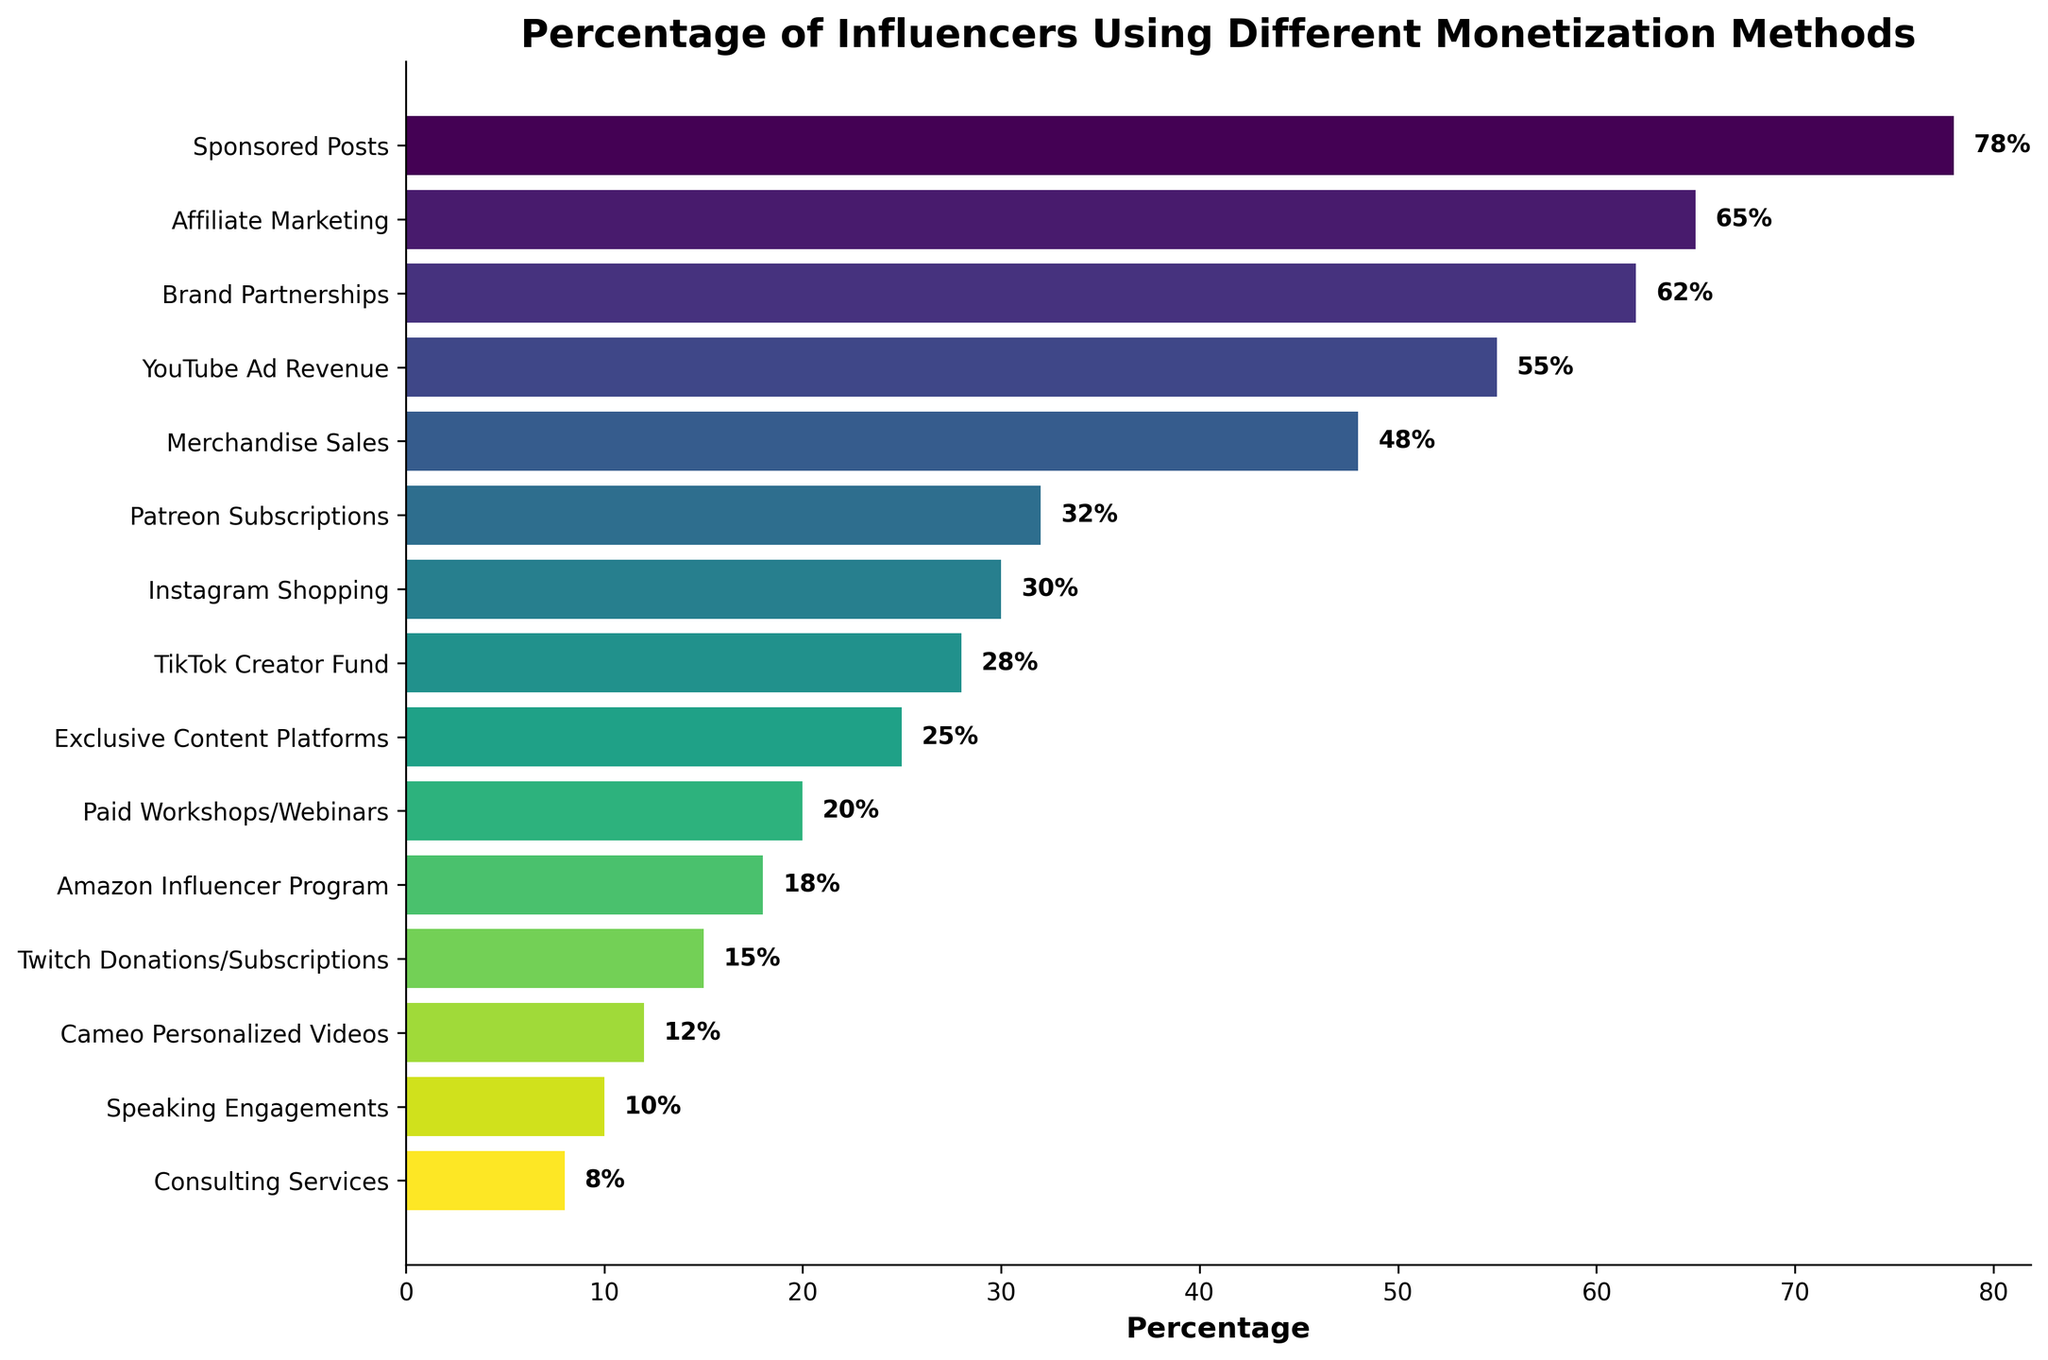Which monetization method is used by the highest percentage of influencers? The longest bar in the chart represents the method used by the highest percentage of influencers. This is indicated by the “Sponsored Posts” bar, which shows a percentage of 78%.
Answer: Sponsored Posts Which monetization method is used by the lowest percentage of influencers? The shortest bar in the chart represents the method used by the lowest percentage of influencers. This is indicated by the “Consulting Services” bar, which shows a percentage of 8%.
Answer: Consulting Services What is the percentage difference between influencers using Sponsored Posts and those using TikTok Creator Fund? The percentage for Sponsored Posts is 78% and for TikTok Creator Fund is 28%. The difference can be calculated by subtracting 28 from 78.
Answer: 50% Which monetization methods have a higher percentage of use than YouTube Ad Revenue? To determine this, identify the methods with bars longer than the YouTube Ad Revenue bar (55%). The methods are Sponsored Posts (78%), Affiliate Marketing (65%), and Brand Partnerships (62%).
Answer: Sponsored Posts, Affiliate Marketing, Brand Partnerships What is the average percentage of influencers using Affiliate Marketing, Brand Partnerships, and Merchandise Sales? The percentages are 65%, 62%, and 48%, respectively. Add these percentages and divide by 3 to find the average: (65 + 62 + 48) / 3 = 175 / 3.
Answer: 58.33% Do more influencers use Patreon Subscriptions or Instagram Shopping? Compare the lengths of the bars for Patreon Subscriptions (32%) and Instagram Shopping (30%). The bar for Patreon Subscriptions is slightly longer.
Answer: Patreon Subscriptions Which monetization method has a percentage closest to 25%? Look for the bar that is closest to 25%. The "Exclusive Content Platforms" method has a percentage of 25%.
Answer: Exclusive Content Platforms How many monetization methods are used by more than 50% of influencers? Count the number of bars with percentages greater than 50%. The methods are Sponsored Posts (78%), Affiliate Marketing (65%), Brand Partnerships (62%), and YouTube Ad Revenue (55%), totaling 4.
Answer: 4 By what percentage do more influencers use Sponsored Posts compared to Merchandise Sales? The percentage for Sponsored Posts is 78% and for Merchandise Sales is 48%. Subtract 48 from 78 to find the difference.
Answer: 30% What is the combined percentage of influencers using Paid Workshops/Webinars and Amazon Influencer Program? Add the percentages of Paid Workshops/Webinars (20%) and Amazon Influencer Program (18%) to find the total: 20 + 18.
Answer: 38% 